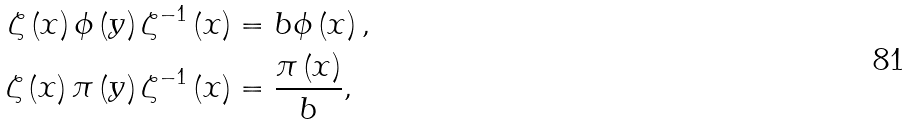<formula> <loc_0><loc_0><loc_500><loc_500>\zeta \left ( x \right ) \phi \left ( y \right ) \zeta ^ { - 1 } \left ( x \right ) & = b \phi \left ( x \right ) , \\ \zeta \left ( x \right ) \pi \left ( y \right ) \zeta ^ { - 1 } \left ( x \right ) & = \frac { \pi \left ( x \right ) } { b } ,</formula> 